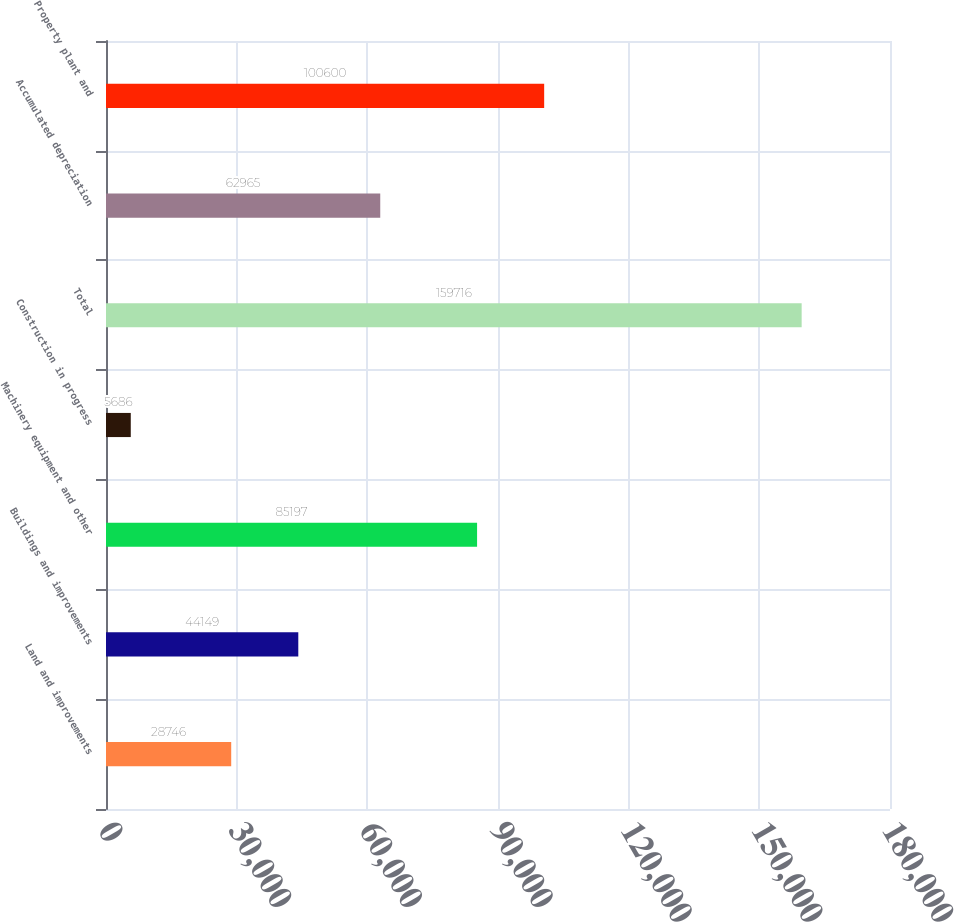Convert chart. <chart><loc_0><loc_0><loc_500><loc_500><bar_chart><fcel>Land and improvements<fcel>Buildings and improvements<fcel>Machinery equipment and other<fcel>Construction in progress<fcel>Total<fcel>Accumulated depreciation<fcel>Property plant and<nl><fcel>28746<fcel>44149<fcel>85197<fcel>5686<fcel>159716<fcel>62965<fcel>100600<nl></chart> 